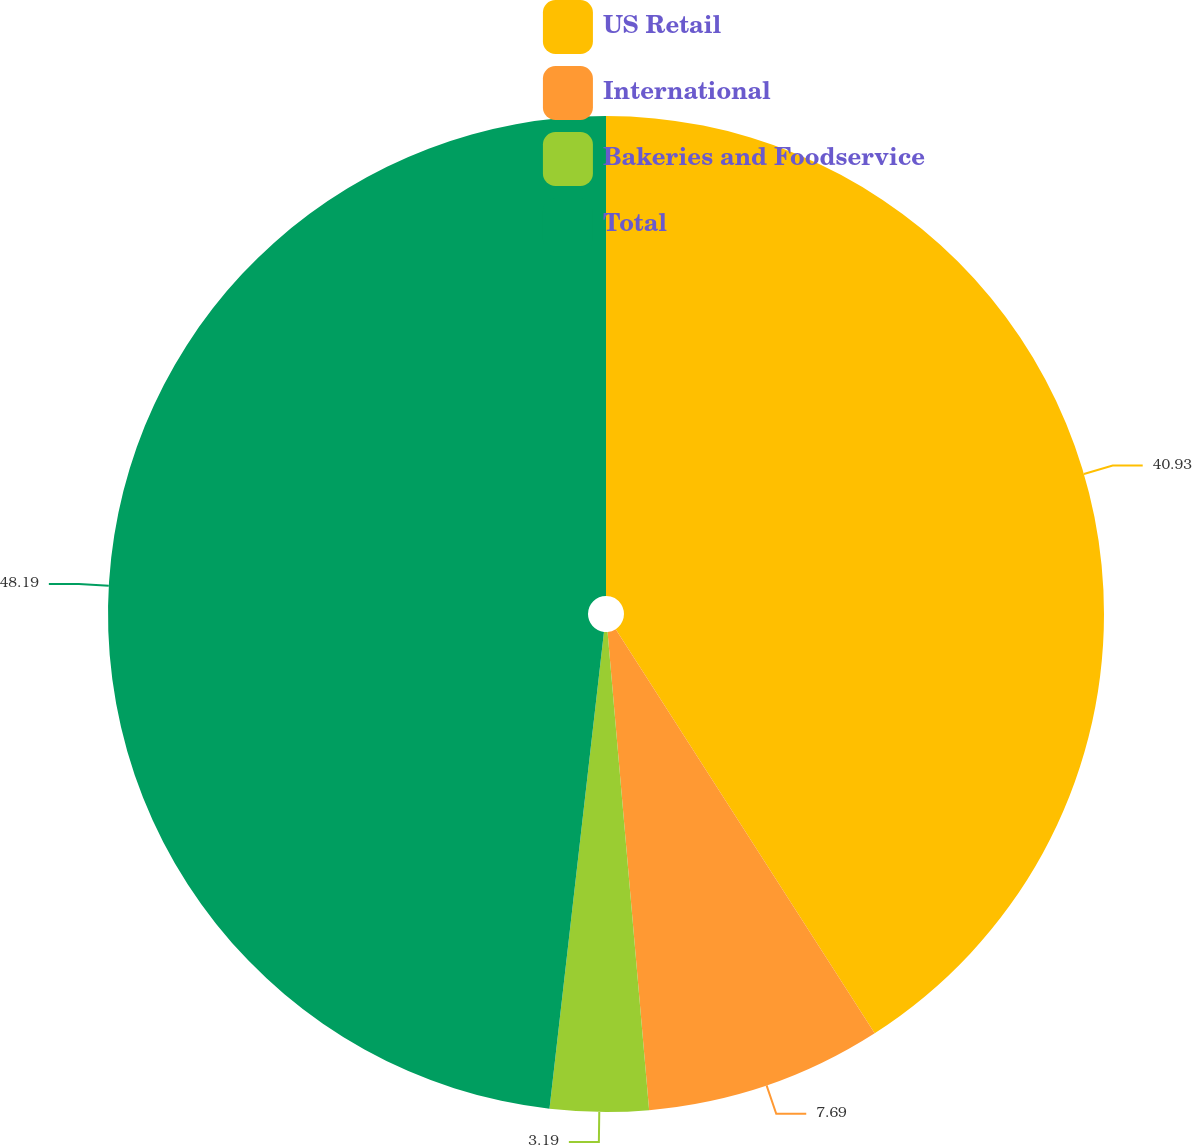Convert chart to OTSL. <chart><loc_0><loc_0><loc_500><loc_500><pie_chart><fcel>US Retail<fcel>International<fcel>Bakeries and Foodservice<fcel>Total<nl><fcel>40.93%<fcel>7.69%<fcel>3.19%<fcel>48.19%<nl></chart> 